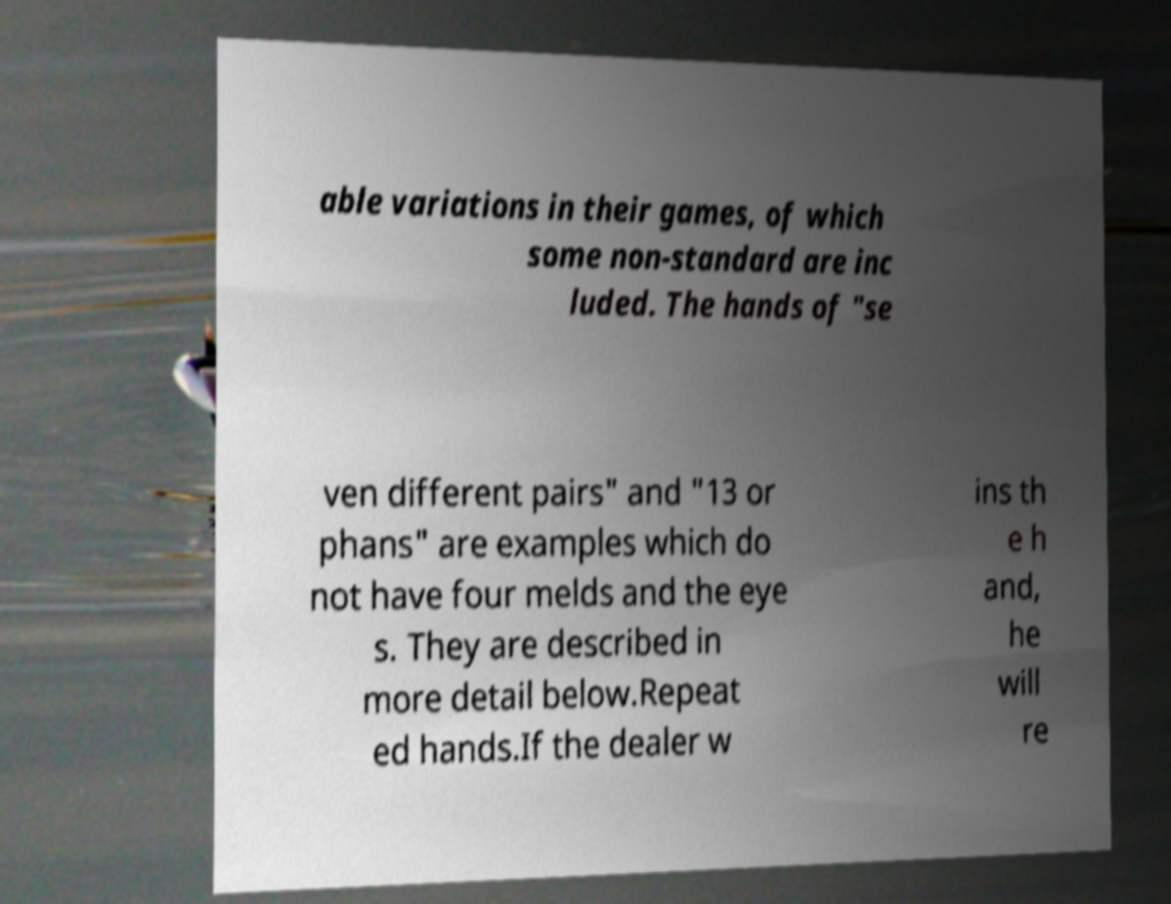For documentation purposes, I need the text within this image transcribed. Could you provide that? able variations in their games, of which some non-standard are inc luded. The hands of "se ven different pairs" and "13 or phans" are examples which do not have four melds and the eye s. They are described in more detail below.Repeat ed hands.If the dealer w ins th e h and, he will re 